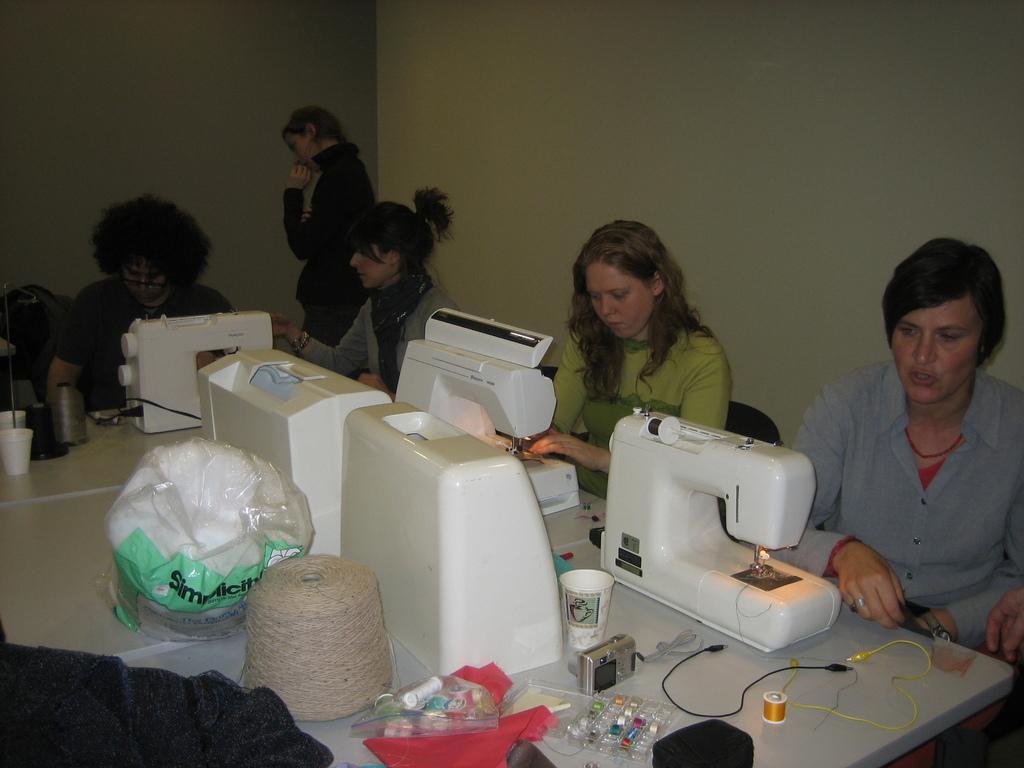Can you describe this image briefly? There are people sitting in front of sewing machines in the foreground area of the image, there are threads, a camera, glass, wire and other objects on the table, there is a person standing and a wall in the background. 